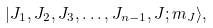Convert formula to latex. <formula><loc_0><loc_0><loc_500><loc_500>| J _ { 1 } , J _ { 2 } , J _ { 3 } , \dots , J _ { n - 1 } , J ; m _ { J } \rangle ,</formula> 